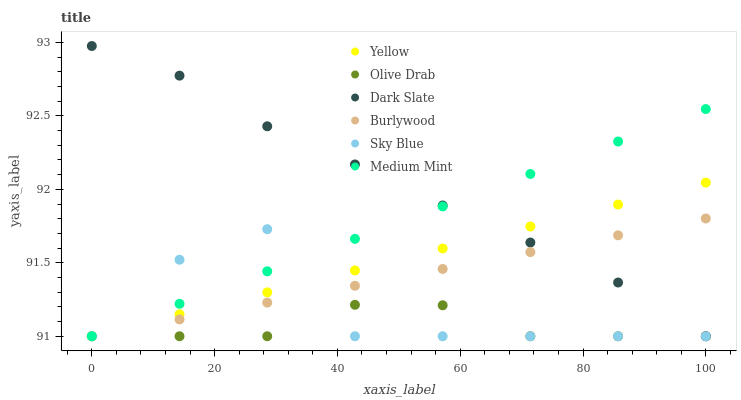Does Olive Drab have the minimum area under the curve?
Answer yes or no. Yes. Does Dark Slate have the maximum area under the curve?
Answer yes or no. Yes. Does Burlywood have the minimum area under the curve?
Answer yes or no. No. Does Burlywood have the maximum area under the curve?
Answer yes or no. No. Is Medium Mint the smoothest?
Answer yes or no. Yes. Is Sky Blue the roughest?
Answer yes or no. Yes. Is Burlywood the smoothest?
Answer yes or no. No. Is Burlywood the roughest?
Answer yes or no. No. Does Medium Mint have the lowest value?
Answer yes or no. Yes. Does Dark Slate have the highest value?
Answer yes or no. Yes. Does Burlywood have the highest value?
Answer yes or no. No. Does Yellow intersect Dark Slate?
Answer yes or no. Yes. Is Yellow less than Dark Slate?
Answer yes or no. No. Is Yellow greater than Dark Slate?
Answer yes or no. No. 